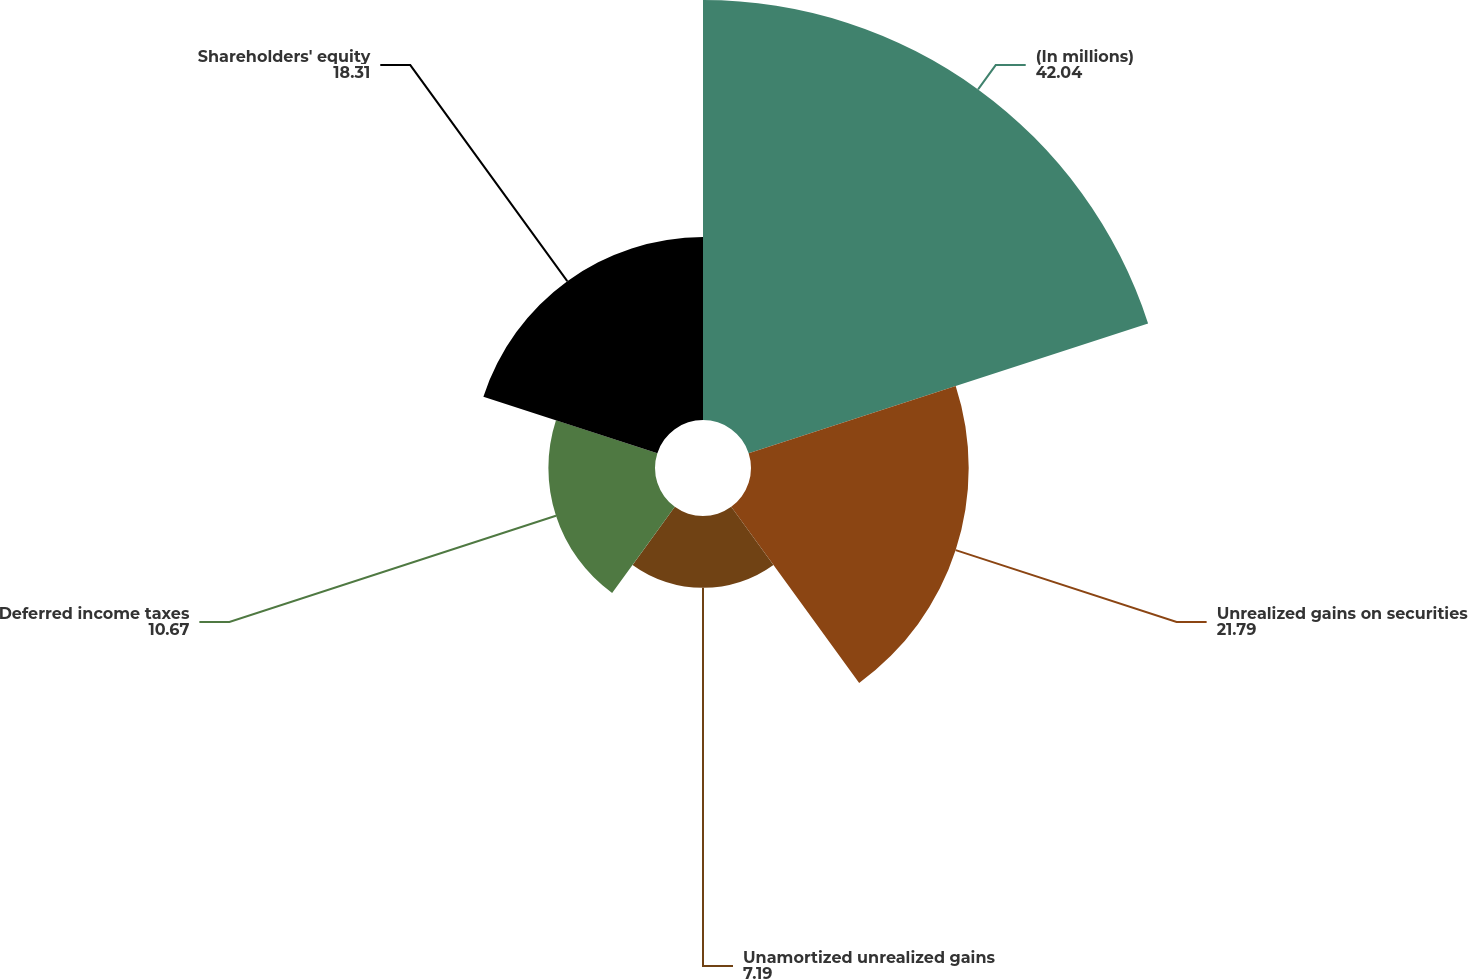Convert chart to OTSL. <chart><loc_0><loc_0><loc_500><loc_500><pie_chart><fcel>(In millions)<fcel>Unrealized gains on securities<fcel>Unamortized unrealized gains<fcel>Deferred income taxes<fcel>Shareholders' equity<nl><fcel>42.04%<fcel>21.79%<fcel>7.19%<fcel>10.67%<fcel>18.31%<nl></chart> 